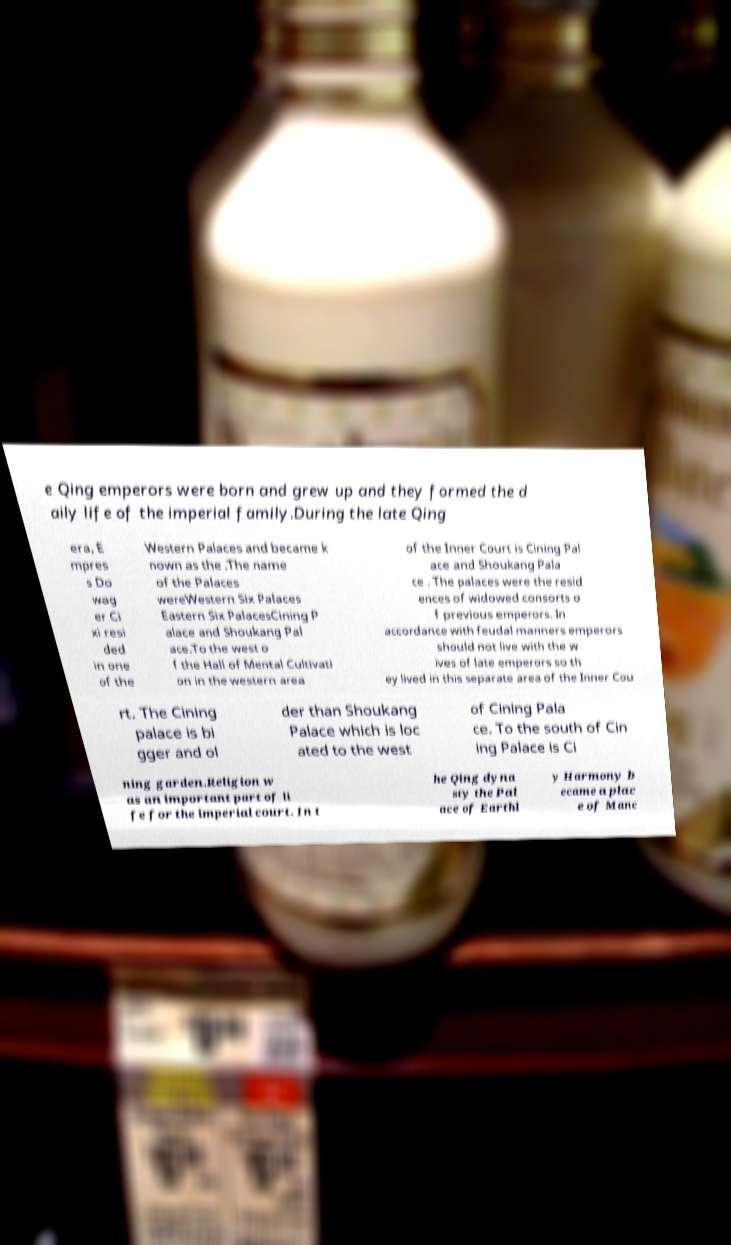I need the written content from this picture converted into text. Can you do that? e Qing emperors were born and grew up and they formed the d aily life of the imperial family.During the late Qing era, E mpres s Do wag er Ci xi resi ded in one of the Western Palaces and became k nown as the .The name of the Palaces wereWestern Six Palaces Eastern Six PalacesCining P alace and Shoukang Pal ace.To the west o f the Hall of Mental Cultivati on in the western area of the Inner Court is Cining Pal ace and Shoukang Pala ce . The palaces were the resid ences of widowed consorts o f previous emperors. In accordance with feudal manners emperors should not live with the w ives of late emperors so th ey lived in this separate area of the Inner Cou rt. The Cining palace is bi gger and ol der than Shoukang Palace which is loc ated to the west of Cining Pala ce. To the south of Cin ing Palace is Ci ning garden.Religion w as an important part of li fe for the imperial court. In t he Qing dyna sty the Pal ace of Earthl y Harmony b ecame a plac e of Manc 